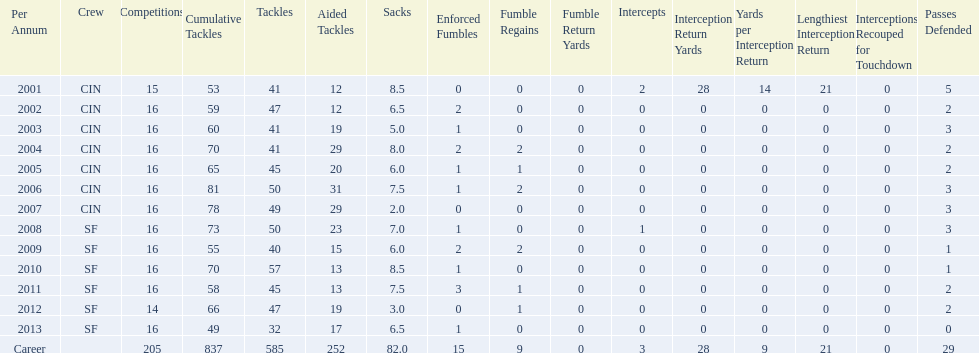How many seasons witnessed a total of 70 or more tackles combined? 5. 